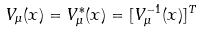Convert formula to latex. <formula><loc_0><loc_0><loc_500><loc_500>V _ { \mu } ( x ) = V ^ { * } _ { \mu } ( x ) = [ V ^ { - 1 } _ { \mu } ( x ) ] ^ { T }</formula> 